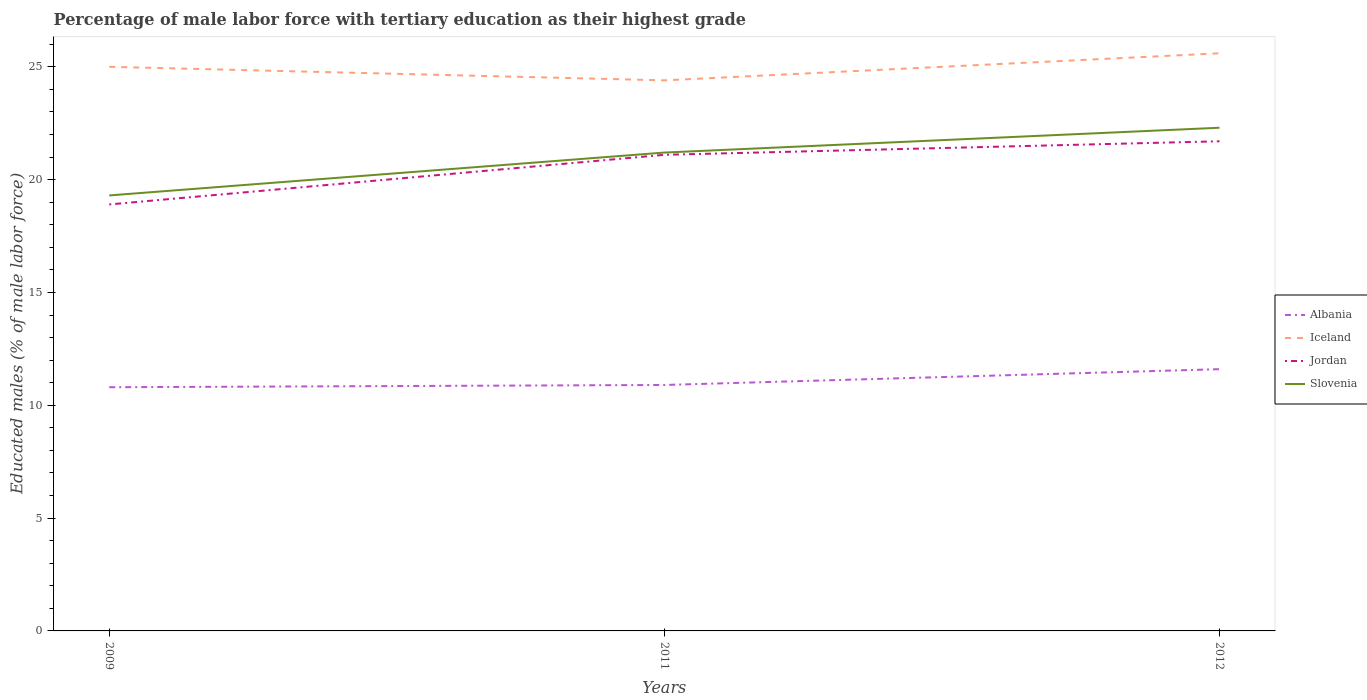How many different coloured lines are there?
Your answer should be very brief. 4. Does the line corresponding to Albania intersect with the line corresponding to Iceland?
Offer a terse response. No. Is the number of lines equal to the number of legend labels?
Give a very brief answer. Yes. Across all years, what is the maximum percentage of male labor force with tertiary education in Slovenia?
Your response must be concise. 19.3. In which year was the percentage of male labor force with tertiary education in Iceland maximum?
Make the answer very short. 2011. What is the total percentage of male labor force with tertiary education in Albania in the graph?
Offer a very short reply. -0.1. What is the difference between the highest and the second highest percentage of male labor force with tertiary education in Iceland?
Offer a very short reply. 1.2. Is the percentage of male labor force with tertiary education in Albania strictly greater than the percentage of male labor force with tertiary education in Jordan over the years?
Ensure brevity in your answer.  Yes. How many years are there in the graph?
Offer a very short reply. 3. Are the values on the major ticks of Y-axis written in scientific E-notation?
Provide a short and direct response. No. Does the graph contain grids?
Give a very brief answer. No. Where does the legend appear in the graph?
Keep it short and to the point. Center right. How many legend labels are there?
Offer a very short reply. 4. How are the legend labels stacked?
Give a very brief answer. Vertical. What is the title of the graph?
Make the answer very short. Percentage of male labor force with tertiary education as their highest grade. Does "Argentina" appear as one of the legend labels in the graph?
Provide a short and direct response. No. What is the label or title of the Y-axis?
Your answer should be compact. Educated males (% of male labor force). What is the Educated males (% of male labor force) in Albania in 2009?
Provide a short and direct response. 10.8. What is the Educated males (% of male labor force) in Iceland in 2009?
Give a very brief answer. 25. What is the Educated males (% of male labor force) of Jordan in 2009?
Ensure brevity in your answer.  18.9. What is the Educated males (% of male labor force) of Slovenia in 2009?
Ensure brevity in your answer.  19.3. What is the Educated males (% of male labor force) in Albania in 2011?
Offer a very short reply. 10.9. What is the Educated males (% of male labor force) in Iceland in 2011?
Provide a succinct answer. 24.4. What is the Educated males (% of male labor force) in Jordan in 2011?
Your answer should be very brief. 21.1. What is the Educated males (% of male labor force) of Slovenia in 2011?
Ensure brevity in your answer.  21.2. What is the Educated males (% of male labor force) in Albania in 2012?
Your answer should be compact. 11.6. What is the Educated males (% of male labor force) in Iceland in 2012?
Your response must be concise. 25.6. What is the Educated males (% of male labor force) in Jordan in 2012?
Keep it short and to the point. 21.7. What is the Educated males (% of male labor force) in Slovenia in 2012?
Provide a short and direct response. 22.3. Across all years, what is the maximum Educated males (% of male labor force) of Albania?
Your answer should be very brief. 11.6. Across all years, what is the maximum Educated males (% of male labor force) in Iceland?
Offer a terse response. 25.6. Across all years, what is the maximum Educated males (% of male labor force) in Jordan?
Provide a short and direct response. 21.7. Across all years, what is the maximum Educated males (% of male labor force) in Slovenia?
Your answer should be very brief. 22.3. Across all years, what is the minimum Educated males (% of male labor force) in Albania?
Provide a succinct answer. 10.8. Across all years, what is the minimum Educated males (% of male labor force) of Iceland?
Your answer should be very brief. 24.4. Across all years, what is the minimum Educated males (% of male labor force) of Jordan?
Give a very brief answer. 18.9. Across all years, what is the minimum Educated males (% of male labor force) of Slovenia?
Keep it short and to the point. 19.3. What is the total Educated males (% of male labor force) of Albania in the graph?
Keep it short and to the point. 33.3. What is the total Educated males (% of male labor force) of Iceland in the graph?
Give a very brief answer. 75. What is the total Educated males (% of male labor force) in Jordan in the graph?
Your response must be concise. 61.7. What is the total Educated males (% of male labor force) of Slovenia in the graph?
Ensure brevity in your answer.  62.8. What is the difference between the Educated males (% of male labor force) of Albania in 2009 and that in 2011?
Your response must be concise. -0.1. What is the difference between the Educated males (% of male labor force) of Jordan in 2009 and that in 2011?
Make the answer very short. -2.2. What is the difference between the Educated males (% of male labor force) in Iceland in 2009 and that in 2012?
Provide a succinct answer. -0.6. What is the difference between the Educated males (% of male labor force) of Jordan in 2009 and that in 2012?
Your response must be concise. -2.8. What is the difference between the Educated males (% of male labor force) of Slovenia in 2011 and that in 2012?
Your answer should be compact. -1.1. What is the difference between the Educated males (% of male labor force) of Albania in 2009 and the Educated males (% of male labor force) of Jordan in 2011?
Keep it short and to the point. -10.3. What is the difference between the Educated males (% of male labor force) of Albania in 2009 and the Educated males (% of male labor force) of Slovenia in 2011?
Keep it short and to the point. -10.4. What is the difference between the Educated males (% of male labor force) of Jordan in 2009 and the Educated males (% of male labor force) of Slovenia in 2011?
Keep it short and to the point. -2.3. What is the difference between the Educated males (% of male labor force) of Albania in 2009 and the Educated males (% of male labor force) of Iceland in 2012?
Offer a very short reply. -14.8. What is the difference between the Educated males (% of male labor force) in Albania in 2009 and the Educated males (% of male labor force) in Jordan in 2012?
Provide a short and direct response. -10.9. What is the difference between the Educated males (% of male labor force) of Iceland in 2009 and the Educated males (% of male labor force) of Jordan in 2012?
Your answer should be very brief. 3.3. What is the difference between the Educated males (% of male labor force) of Iceland in 2009 and the Educated males (% of male labor force) of Slovenia in 2012?
Provide a succinct answer. 2.7. What is the difference between the Educated males (% of male labor force) of Jordan in 2009 and the Educated males (% of male labor force) of Slovenia in 2012?
Provide a short and direct response. -3.4. What is the difference between the Educated males (% of male labor force) in Albania in 2011 and the Educated males (% of male labor force) in Iceland in 2012?
Your answer should be very brief. -14.7. What is the difference between the Educated males (% of male labor force) in Albania in 2011 and the Educated males (% of male labor force) in Slovenia in 2012?
Your answer should be very brief. -11.4. What is the difference between the Educated males (% of male labor force) in Iceland in 2011 and the Educated males (% of male labor force) in Jordan in 2012?
Offer a very short reply. 2.7. What is the average Educated males (% of male labor force) of Iceland per year?
Provide a succinct answer. 25. What is the average Educated males (% of male labor force) of Jordan per year?
Your answer should be compact. 20.57. What is the average Educated males (% of male labor force) of Slovenia per year?
Provide a succinct answer. 20.93. In the year 2009, what is the difference between the Educated males (% of male labor force) in Albania and Educated males (% of male labor force) in Iceland?
Provide a short and direct response. -14.2. In the year 2009, what is the difference between the Educated males (% of male labor force) in Albania and Educated males (% of male labor force) in Jordan?
Offer a very short reply. -8.1. In the year 2009, what is the difference between the Educated males (% of male labor force) in Albania and Educated males (% of male labor force) in Slovenia?
Your answer should be very brief. -8.5. In the year 2009, what is the difference between the Educated males (% of male labor force) of Iceland and Educated males (% of male labor force) of Jordan?
Provide a succinct answer. 6.1. In the year 2009, what is the difference between the Educated males (% of male labor force) in Iceland and Educated males (% of male labor force) in Slovenia?
Ensure brevity in your answer.  5.7. In the year 2011, what is the difference between the Educated males (% of male labor force) in Albania and Educated males (% of male labor force) in Iceland?
Provide a succinct answer. -13.5. In the year 2011, what is the difference between the Educated males (% of male labor force) of Albania and Educated males (% of male labor force) of Slovenia?
Provide a short and direct response. -10.3. In the year 2011, what is the difference between the Educated males (% of male labor force) in Iceland and Educated males (% of male labor force) in Jordan?
Provide a succinct answer. 3.3. In the year 2012, what is the difference between the Educated males (% of male labor force) in Albania and Educated males (% of male labor force) in Iceland?
Provide a succinct answer. -14. In the year 2012, what is the difference between the Educated males (% of male labor force) of Albania and Educated males (% of male labor force) of Slovenia?
Keep it short and to the point. -10.7. In the year 2012, what is the difference between the Educated males (% of male labor force) in Iceland and Educated males (% of male labor force) in Jordan?
Your answer should be compact. 3.9. In the year 2012, what is the difference between the Educated males (% of male labor force) in Iceland and Educated males (% of male labor force) in Slovenia?
Offer a terse response. 3.3. What is the ratio of the Educated males (% of male labor force) of Iceland in 2009 to that in 2011?
Provide a short and direct response. 1.02. What is the ratio of the Educated males (% of male labor force) in Jordan in 2009 to that in 2011?
Your response must be concise. 0.9. What is the ratio of the Educated males (% of male labor force) in Slovenia in 2009 to that in 2011?
Keep it short and to the point. 0.91. What is the ratio of the Educated males (% of male labor force) in Albania in 2009 to that in 2012?
Offer a terse response. 0.93. What is the ratio of the Educated males (% of male labor force) of Iceland in 2009 to that in 2012?
Your response must be concise. 0.98. What is the ratio of the Educated males (% of male labor force) of Jordan in 2009 to that in 2012?
Make the answer very short. 0.87. What is the ratio of the Educated males (% of male labor force) in Slovenia in 2009 to that in 2012?
Give a very brief answer. 0.87. What is the ratio of the Educated males (% of male labor force) of Albania in 2011 to that in 2012?
Provide a short and direct response. 0.94. What is the ratio of the Educated males (% of male labor force) in Iceland in 2011 to that in 2012?
Offer a very short reply. 0.95. What is the ratio of the Educated males (% of male labor force) of Jordan in 2011 to that in 2012?
Your response must be concise. 0.97. What is the ratio of the Educated males (% of male labor force) in Slovenia in 2011 to that in 2012?
Your answer should be compact. 0.95. What is the difference between the highest and the second highest Educated males (% of male labor force) in Iceland?
Offer a terse response. 0.6. What is the difference between the highest and the second highest Educated males (% of male labor force) in Slovenia?
Give a very brief answer. 1.1. What is the difference between the highest and the lowest Educated males (% of male labor force) in Albania?
Keep it short and to the point. 0.8. What is the difference between the highest and the lowest Educated males (% of male labor force) of Iceland?
Your answer should be compact. 1.2. 